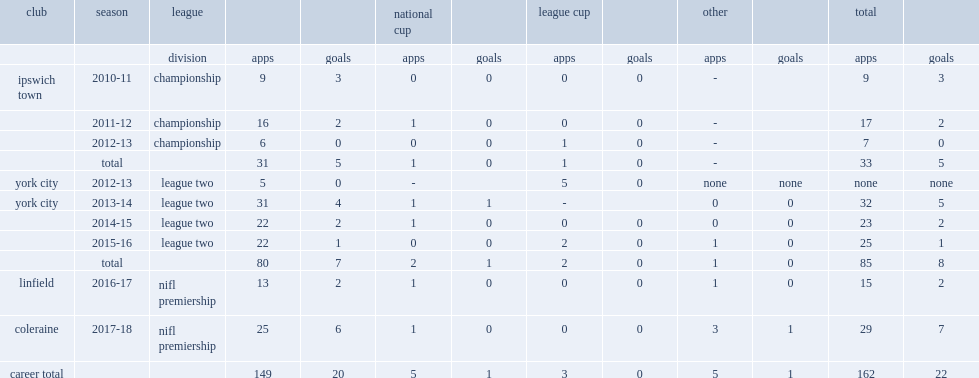Can you give me this table as a dict? {'header': ['club', 'season', 'league', '', '', 'national cup', '', 'league cup', '', 'other', '', 'total', ''], 'rows': [['', '', 'division', 'apps', 'goals', 'apps', 'goals', 'apps', 'goals', 'apps', 'goals', 'apps', 'goals'], ['ipswich town', '2010-11', 'championship', '9', '3', '0', '0', '0', '0', '-', '', '9', '3'], ['', '2011-12', 'championship', '16', '2', '1', '0', '0', '0', '-', '', '17', '2'], ['', '2012-13', 'championship', '6', '0', '0', '0', '1', '0', '-', '', '7', '0'], ['', 'total', '', '31', '5', '1', '0', '1', '0', '-', '', '33', '5'], ['york city', '2012-13', 'league two', '5', '0', '-', '', '5', '0', 'none', 'none', 'none', 'none'], ['york city', '2013-14', 'league two', '31', '4', '1', '1', '-', '', '0', '0', '32', '5'], ['', '2014-15', 'league two', '22', '2', '1', '0', '0', '0', '0', '0', '23', '2'], ['', '2015-16', 'league two', '22', '1', '0', '0', '2', '0', '1', '0', '25', '1'], ['', 'total', '', '80', '7', '2', '1', '2', '0', '1', '0', '85', '8'], ['linfield', '2016-17', 'nifl premiership', '13', '2', '1', '0', '0', '0', '1', '0', '15', '2'], ['coleraine', '2017-18', 'nifl premiership', '25', '6', '1', '0', '0', '0', '3', '1', '29', '7'], ['career total', '', '', '149', '20', '5', '1', '3', '0', '5', '1', '162', '22']]} How many goals did josh carson score for linfield totally? 2.0. 